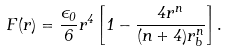Convert formula to latex. <formula><loc_0><loc_0><loc_500><loc_500>F ( r ) = \frac { \epsilon _ { 0 } } { 6 } r ^ { 4 } \left [ 1 - \frac { 4 r ^ { n } } { ( n + 4 ) r _ { b } ^ { n } } \right ] .</formula> 